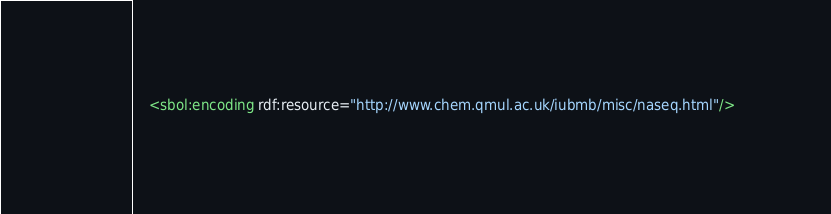<code> <loc_0><loc_0><loc_500><loc_500><_XML_>    <sbol:encoding rdf:resource="http://www.chem.qmul.ac.uk/iubmb/misc/naseq.html"/></code> 